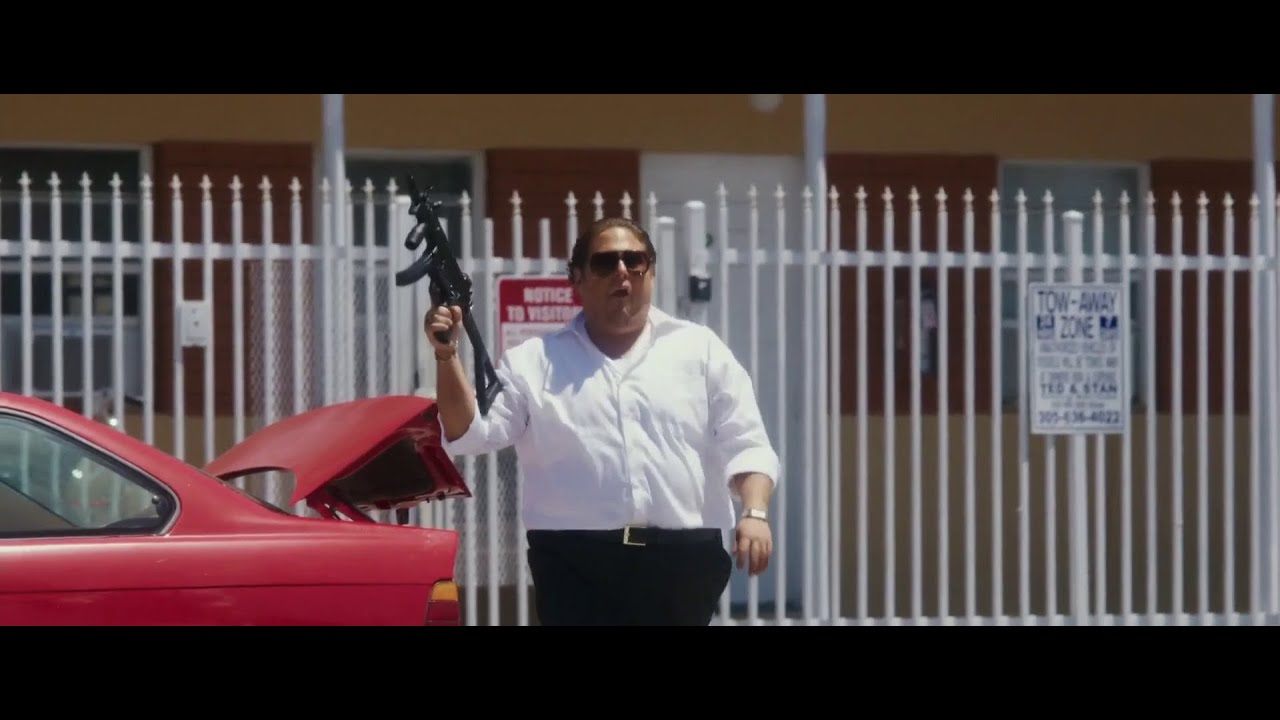Can you tell me more about the setting? Why might there be a 'NO VISITORS' sign? The setting is likely a secure or private area, based on the white fence with the 'NOTICE NO VISITORS' sign, which suggests restrictions on access. This could be due to the presence of valuable property or a need for privacy within the compound. The urban elements and the style of buildings hint at a residential or semi-commercial area. 